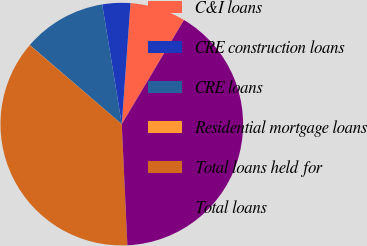Convert chart to OTSL. <chart><loc_0><loc_0><loc_500><loc_500><pie_chart><fcel>C&I loans<fcel>CRE construction loans<fcel>CRE loans<fcel>Residential mortgage loans<fcel>Total loans held for<fcel>Total loans<nl><fcel>7.42%<fcel>3.72%<fcel>11.12%<fcel>0.02%<fcel>37.01%<fcel>40.7%<nl></chart> 